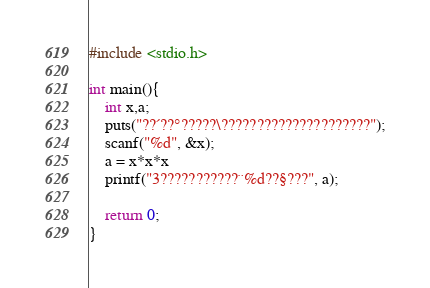<code> <loc_0><loc_0><loc_500><loc_500><_C_>#include <stdio.h>

int main(){
    int x,a;
    puts("??´??°?????\?????????????????????");
    scanf("%d", &x);
    a = x*x*x
    printf("3???????????¨%d??§???", a);

    return 0;
}</code> 